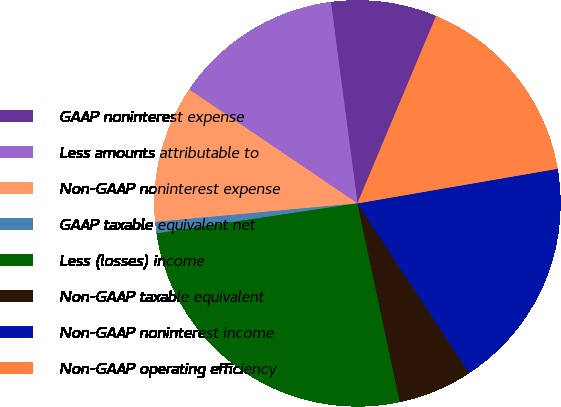Convert chart to OTSL. <chart><loc_0><loc_0><loc_500><loc_500><pie_chart><fcel>GAAP noninterest expense<fcel>Less amounts attributable to<fcel>Non-GAAP noninterest expense<fcel>GAAP taxable equivalent net<fcel>Less (losses) income<fcel>Non-GAAP taxable equivalent<fcel>Non-GAAP noninterest income<fcel>Non-GAAP operating efficiency<nl><fcel>8.42%<fcel>13.44%<fcel>10.93%<fcel>0.9%<fcel>25.98%<fcel>5.92%<fcel>18.46%<fcel>15.95%<nl></chart> 